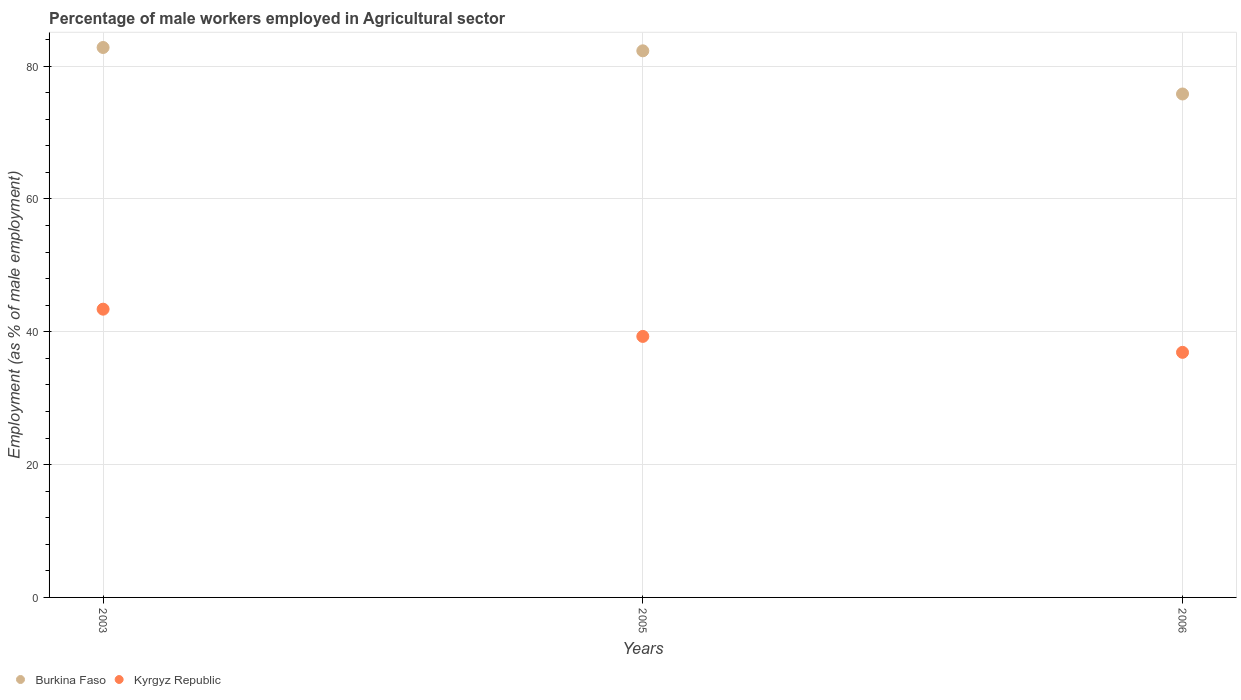What is the percentage of male workers employed in Agricultural sector in Kyrgyz Republic in 2003?
Provide a succinct answer. 43.4. Across all years, what is the maximum percentage of male workers employed in Agricultural sector in Burkina Faso?
Your response must be concise. 82.8. Across all years, what is the minimum percentage of male workers employed in Agricultural sector in Kyrgyz Republic?
Ensure brevity in your answer.  36.9. In which year was the percentage of male workers employed in Agricultural sector in Kyrgyz Republic maximum?
Your response must be concise. 2003. In which year was the percentage of male workers employed in Agricultural sector in Kyrgyz Republic minimum?
Make the answer very short. 2006. What is the total percentage of male workers employed in Agricultural sector in Kyrgyz Republic in the graph?
Ensure brevity in your answer.  119.6. What is the difference between the percentage of male workers employed in Agricultural sector in Kyrgyz Republic in 2005 and that in 2006?
Your response must be concise. 2.4. What is the difference between the percentage of male workers employed in Agricultural sector in Burkina Faso in 2003 and the percentage of male workers employed in Agricultural sector in Kyrgyz Republic in 2005?
Offer a very short reply. 43.5. What is the average percentage of male workers employed in Agricultural sector in Kyrgyz Republic per year?
Make the answer very short. 39.87. In the year 2006, what is the difference between the percentage of male workers employed in Agricultural sector in Burkina Faso and percentage of male workers employed in Agricultural sector in Kyrgyz Republic?
Provide a succinct answer. 38.9. In how many years, is the percentage of male workers employed in Agricultural sector in Burkina Faso greater than 4 %?
Ensure brevity in your answer.  3. What is the ratio of the percentage of male workers employed in Agricultural sector in Burkina Faso in 2003 to that in 2006?
Offer a very short reply. 1.09. Is the percentage of male workers employed in Agricultural sector in Kyrgyz Republic in 2003 less than that in 2005?
Provide a succinct answer. No. What is the difference between the highest and the second highest percentage of male workers employed in Agricultural sector in Kyrgyz Republic?
Provide a succinct answer. 4.1. What is the difference between the highest and the lowest percentage of male workers employed in Agricultural sector in Burkina Faso?
Your answer should be compact. 7. Does the percentage of male workers employed in Agricultural sector in Burkina Faso monotonically increase over the years?
Give a very brief answer. No. Is the percentage of male workers employed in Agricultural sector in Kyrgyz Republic strictly greater than the percentage of male workers employed in Agricultural sector in Burkina Faso over the years?
Offer a very short reply. No. How many dotlines are there?
Ensure brevity in your answer.  2. Where does the legend appear in the graph?
Offer a terse response. Bottom left. How many legend labels are there?
Offer a very short reply. 2. What is the title of the graph?
Keep it short and to the point. Percentage of male workers employed in Agricultural sector. Does "Brunei Darussalam" appear as one of the legend labels in the graph?
Your response must be concise. No. What is the label or title of the Y-axis?
Provide a succinct answer. Employment (as % of male employment). What is the Employment (as % of male employment) of Burkina Faso in 2003?
Provide a succinct answer. 82.8. What is the Employment (as % of male employment) of Kyrgyz Republic in 2003?
Provide a short and direct response. 43.4. What is the Employment (as % of male employment) in Burkina Faso in 2005?
Provide a succinct answer. 82.3. What is the Employment (as % of male employment) in Kyrgyz Republic in 2005?
Your answer should be compact. 39.3. What is the Employment (as % of male employment) in Burkina Faso in 2006?
Offer a very short reply. 75.8. What is the Employment (as % of male employment) of Kyrgyz Republic in 2006?
Keep it short and to the point. 36.9. Across all years, what is the maximum Employment (as % of male employment) in Burkina Faso?
Make the answer very short. 82.8. Across all years, what is the maximum Employment (as % of male employment) of Kyrgyz Republic?
Your answer should be very brief. 43.4. Across all years, what is the minimum Employment (as % of male employment) of Burkina Faso?
Give a very brief answer. 75.8. Across all years, what is the minimum Employment (as % of male employment) of Kyrgyz Republic?
Provide a short and direct response. 36.9. What is the total Employment (as % of male employment) in Burkina Faso in the graph?
Ensure brevity in your answer.  240.9. What is the total Employment (as % of male employment) in Kyrgyz Republic in the graph?
Keep it short and to the point. 119.6. What is the difference between the Employment (as % of male employment) in Burkina Faso in 2003 and that in 2005?
Offer a terse response. 0.5. What is the difference between the Employment (as % of male employment) in Kyrgyz Republic in 2003 and that in 2005?
Your response must be concise. 4.1. What is the difference between the Employment (as % of male employment) in Burkina Faso in 2005 and that in 2006?
Ensure brevity in your answer.  6.5. What is the difference between the Employment (as % of male employment) of Kyrgyz Republic in 2005 and that in 2006?
Make the answer very short. 2.4. What is the difference between the Employment (as % of male employment) of Burkina Faso in 2003 and the Employment (as % of male employment) of Kyrgyz Republic in 2005?
Offer a very short reply. 43.5. What is the difference between the Employment (as % of male employment) of Burkina Faso in 2003 and the Employment (as % of male employment) of Kyrgyz Republic in 2006?
Provide a succinct answer. 45.9. What is the difference between the Employment (as % of male employment) in Burkina Faso in 2005 and the Employment (as % of male employment) in Kyrgyz Republic in 2006?
Give a very brief answer. 45.4. What is the average Employment (as % of male employment) in Burkina Faso per year?
Give a very brief answer. 80.3. What is the average Employment (as % of male employment) in Kyrgyz Republic per year?
Ensure brevity in your answer.  39.87. In the year 2003, what is the difference between the Employment (as % of male employment) in Burkina Faso and Employment (as % of male employment) in Kyrgyz Republic?
Make the answer very short. 39.4. In the year 2006, what is the difference between the Employment (as % of male employment) in Burkina Faso and Employment (as % of male employment) in Kyrgyz Republic?
Your answer should be very brief. 38.9. What is the ratio of the Employment (as % of male employment) of Kyrgyz Republic in 2003 to that in 2005?
Give a very brief answer. 1.1. What is the ratio of the Employment (as % of male employment) of Burkina Faso in 2003 to that in 2006?
Offer a terse response. 1.09. What is the ratio of the Employment (as % of male employment) of Kyrgyz Republic in 2003 to that in 2006?
Your answer should be very brief. 1.18. What is the ratio of the Employment (as % of male employment) of Burkina Faso in 2005 to that in 2006?
Offer a terse response. 1.09. What is the ratio of the Employment (as % of male employment) in Kyrgyz Republic in 2005 to that in 2006?
Make the answer very short. 1.06. What is the difference between the highest and the second highest Employment (as % of male employment) of Burkina Faso?
Offer a terse response. 0.5. What is the difference between the highest and the second highest Employment (as % of male employment) of Kyrgyz Republic?
Keep it short and to the point. 4.1. What is the difference between the highest and the lowest Employment (as % of male employment) of Burkina Faso?
Give a very brief answer. 7. What is the difference between the highest and the lowest Employment (as % of male employment) of Kyrgyz Republic?
Provide a succinct answer. 6.5. 